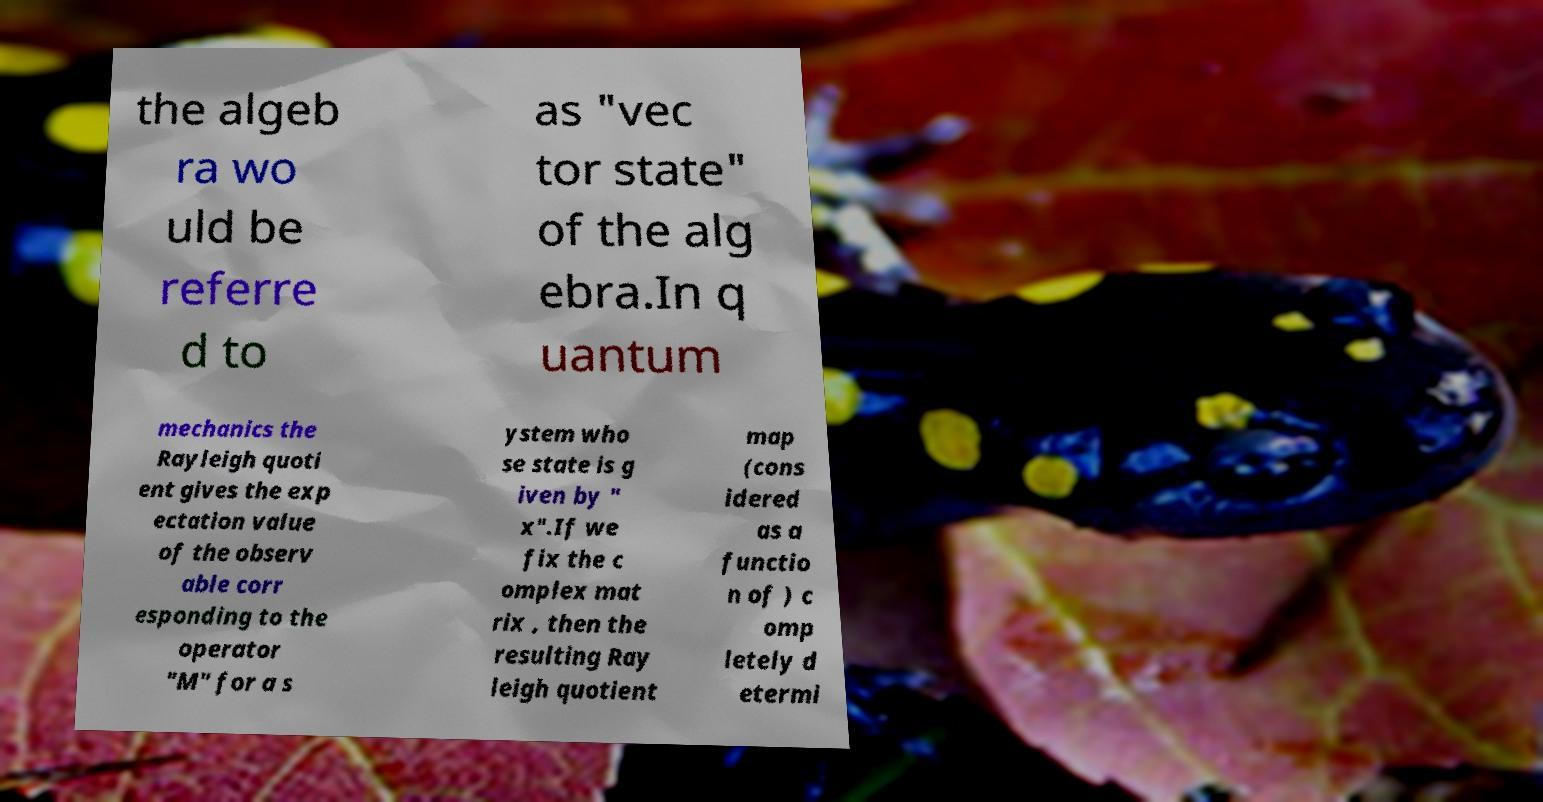Could you assist in decoding the text presented in this image and type it out clearly? the algeb ra wo uld be referre d to as "vec tor state" of the alg ebra.In q uantum mechanics the Rayleigh quoti ent gives the exp ectation value of the observ able corr esponding to the operator "M" for a s ystem who se state is g iven by " x".If we fix the c omplex mat rix , then the resulting Ray leigh quotient map (cons idered as a functio n of ) c omp letely d etermi 